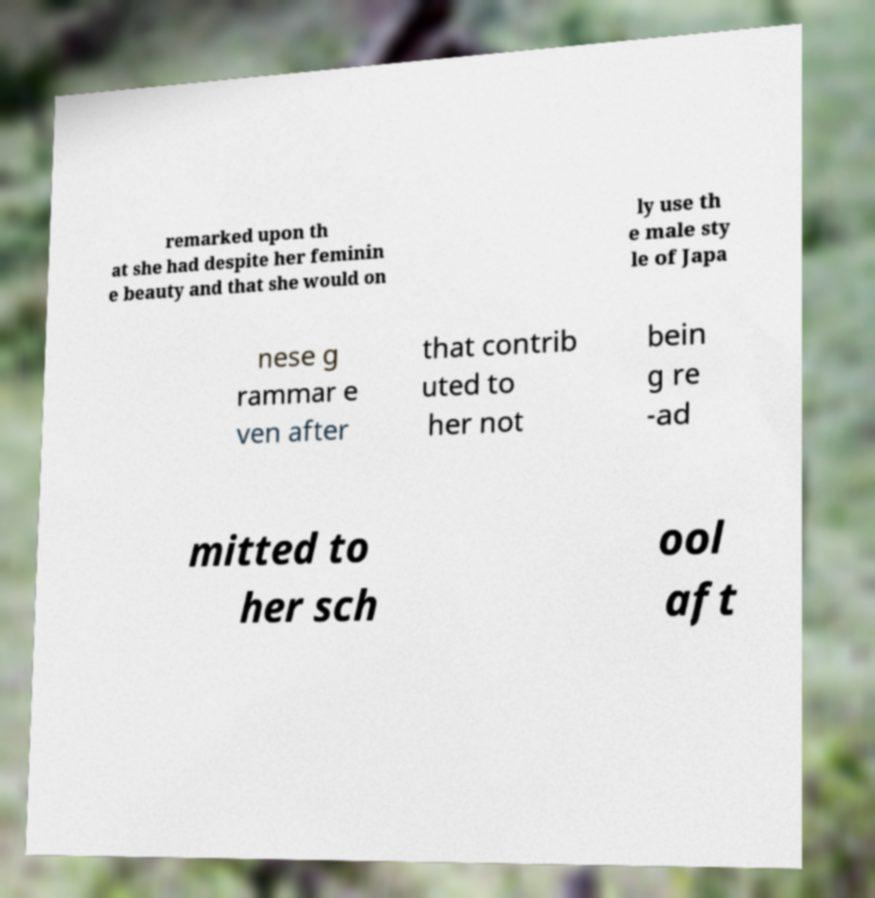Please identify and transcribe the text found in this image. remarked upon th at she had despite her feminin e beauty and that she would on ly use th e male sty le of Japa nese g rammar e ven after that contrib uted to her not bein g re -ad mitted to her sch ool aft 